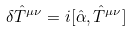Convert formula to latex. <formula><loc_0><loc_0><loc_500><loc_500>\delta \hat { T } ^ { \mu \nu } = i [ \hat { \alpha } , \hat { T } ^ { \mu \nu } ]</formula> 